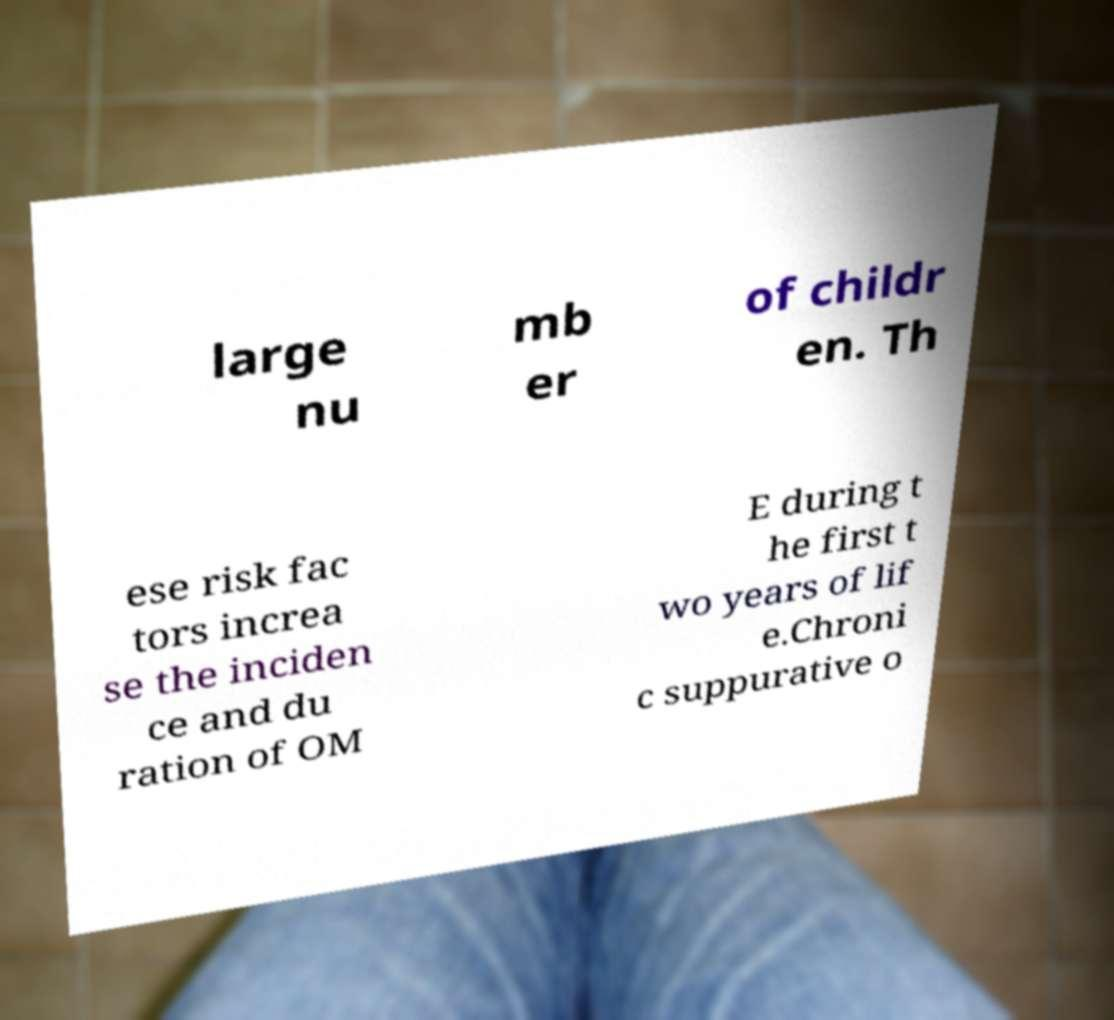I need the written content from this picture converted into text. Can you do that? large nu mb er of childr en. Th ese risk fac tors increa se the inciden ce and du ration of OM E during t he first t wo years of lif e.Chroni c suppurative o 